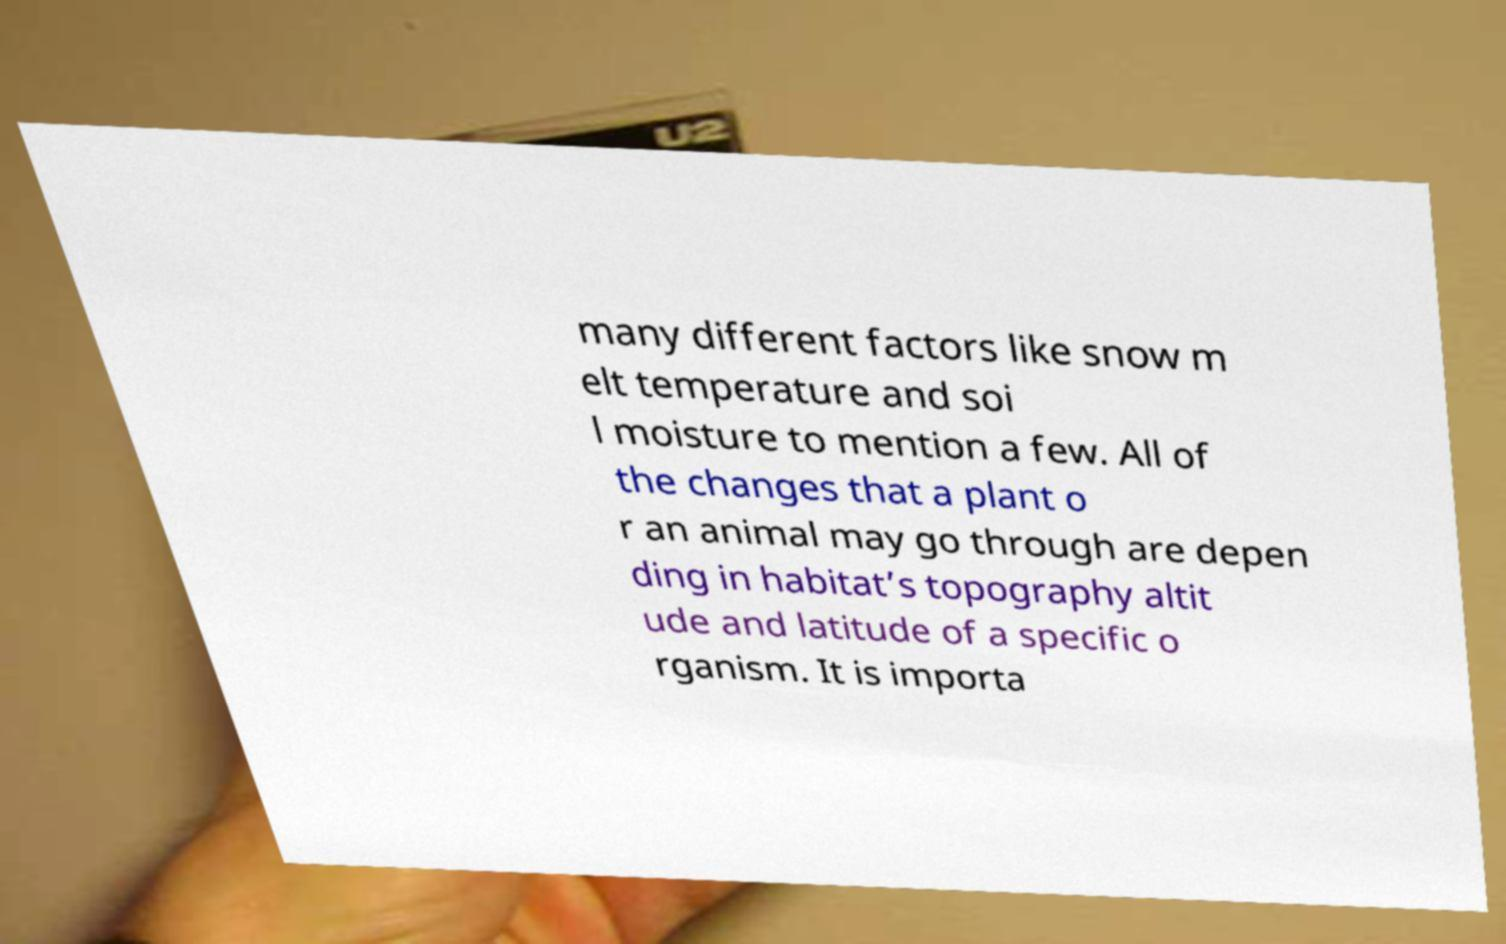For documentation purposes, I need the text within this image transcribed. Could you provide that? many different factors like snow m elt temperature and soi l moisture to mention a few. All of the changes that a plant o r an animal may go through are depen ding in habitat’s topography altit ude and latitude of a specific o rganism. It is importa 